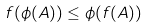Convert formula to latex. <formula><loc_0><loc_0><loc_500><loc_500>f ( \phi ( A ) ) \leq \phi ( f ( A ) )</formula> 